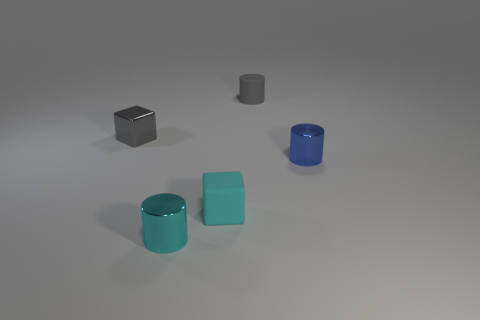There is a tiny object that is the same color as the rubber cube; what shape is it?
Offer a terse response. Cylinder. What number of other objects are the same size as the gray shiny cube?
Offer a terse response. 4. How big is the block that is in front of the small block that is on the left side of the cyan matte cube?
Your answer should be compact. Small. The metallic thing that is on the right side of the tiny gray thing that is behind the metallic thing that is left of the cyan metal cylinder is what color?
Keep it short and to the point. Blue. There is a shiny thing that is behind the rubber block and on the left side of the tiny matte cylinder; how big is it?
Your answer should be compact. Small. How many other objects are there of the same shape as the gray metal thing?
Provide a short and direct response. 1. What number of spheres are either yellow things or tiny blue objects?
Keep it short and to the point. 0. There is a tiny cyan thing behind the small cylinder left of the tiny matte cylinder; are there any small gray shiny cubes that are in front of it?
Give a very brief answer. No. What is the color of the tiny matte thing that is the same shape as the small blue shiny object?
Your response must be concise. Gray. What number of purple objects are either cylinders or tiny metallic objects?
Give a very brief answer. 0. 